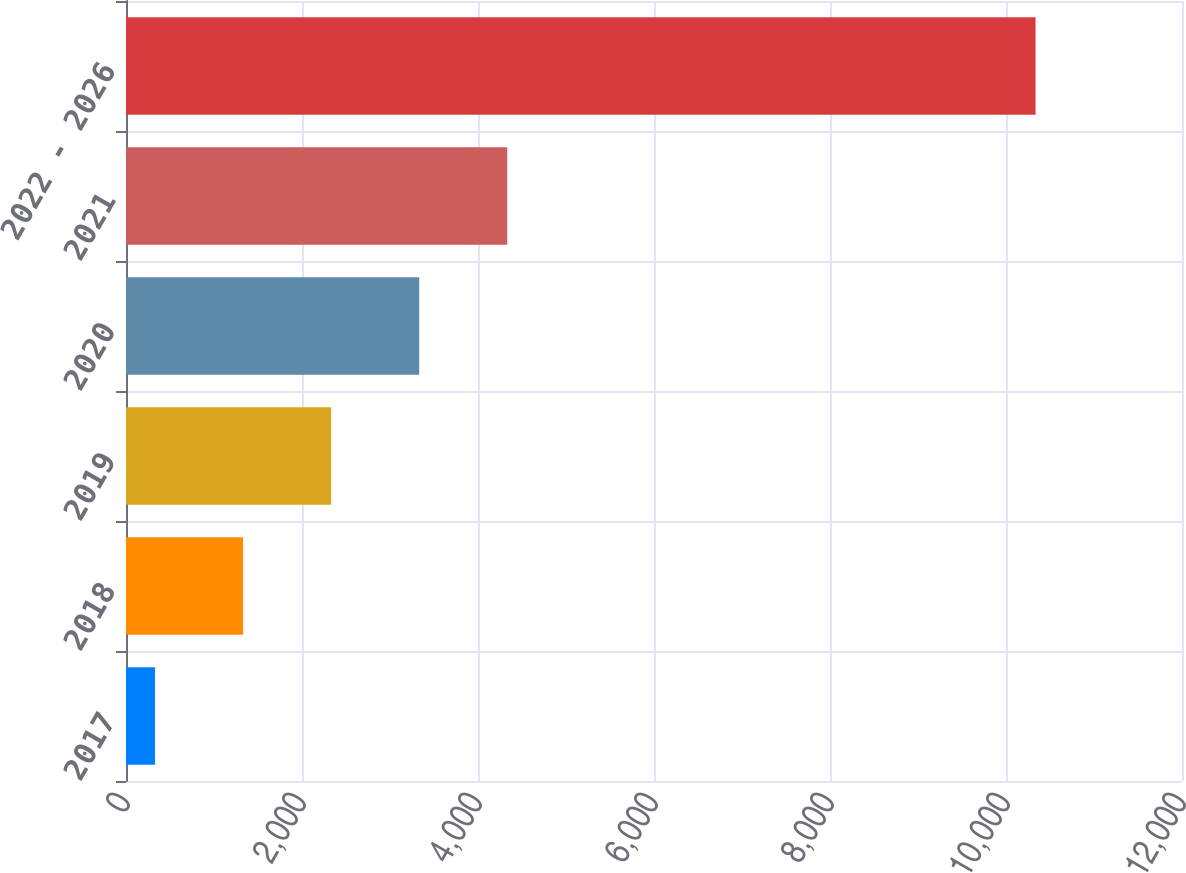Convert chart to OTSL. <chart><loc_0><loc_0><loc_500><loc_500><bar_chart><fcel>2017<fcel>2018<fcel>2019<fcel>2020<fcel>2021<fcel>2022 - 2026<nl><fcel>330<fcel>1330.6<fcel>2331.2<fcel>3331.8<fcel>4332.4<fcel>10336<nl></chart> 